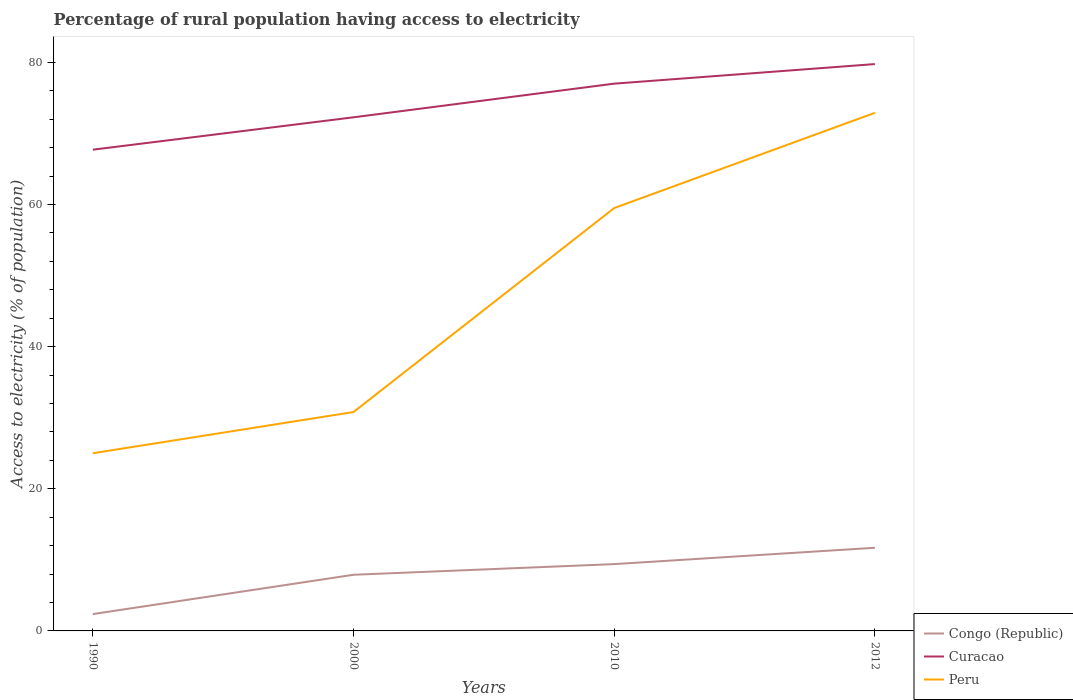How many different coloured lines are there?
Make the answer very short. 3. Across all years, what is the maximum percentage of rural population having access to electricity in Congo (Republic)?
Give a very brief answer. 2.37. In which year was the percentage of rural population having access to electricity in Congo (Republic) maximum?
Your response must be concise. 1990. What is the total percentage of rural population having access to electricity in Peru in the graph?
Provide a short and direct response. -28.7. What is the difference between the highest and the second highest percentage of rural population having access to electricity in Congo (Republic)?
Offer a terse response. 9.33. How many lines are there?
Keep it short and to the point. 3. How many years are there in the graph?
Ensure brevity in your answer.  4. Are the values on the major ticks of Y-axis written in scientific E-notation?
Your response must be concise. No. Does the graph contain any zero values?
Keep it short and to the point. No. Does the graph contain grids?
Offer a terse response. No. How are the legend labels stacked?
Your answer should be compact. Vertical. What is the title of the graph?
Keep it short and to the point. Percentage of rural population having access to electricity. Does "Eritrea" appear as one of the legend labels in the graph?
Your answer should be compact. No. What is the label or title of the Y-axis?
Provide a short and direct response. Access to electricity (% of population). What is the Access to electricity (% of population) of Congo (Republic) in 1990?
Make the answer very short. 2.37. What is the Access to electricity (% of population) of Curacao in 1990?
Provide a succinct answer. 67.71. What is the Access to electricity (% of population) in Peru in 1990?
Give a very brief answer. 25. What is the Access to electricity (% of population) of Curacao in 2000?
Your answer should be very brief. 72.27. What is the Access to electricity (% of population) in Peru in 2000?
Your answer should be very brief. 30.8. What is the Access to electricity (% of population) in Congo (Republic) in 2010?
Keep it short and to the point. 9.4. What is the Access to electricity (% of population) of Curacao in 2010?
Keep it short and to the point. 77. What is the Access to electricity (% of population) in Peru in 2010?
Make the answer very short. 59.5. What is the Access to electricity (% of population) of Curacao in 2012?
Keep it short and to the point. 79.75. What is the Access to electricity (% of population) of Peru in 2012?
Make the answer very short. 72.9. Across all years, what is the maximum Access to electricity (% of population) of Curacao?
Make the answer very short. 79.75. Across all years, what is the maximum Access to electricity (% of population) in Peru?
Make the answer very short. 72.9. Across all years, what is the minimum Access to electricity (% of population) of Congo (Republic)?
Make the answer very short. 2.37. Across all years, what is the minimum Access to electricity (% of population) in Curacao?
Your answer should be compact. 67.71. What is the total Access to electricity (% of population) of Congo (Republic) in the graph?
Offer a very short reply. 31.37. What is the total Access to electricity (% of population) in Curacao in the graph?
Ensure brevity in your answer.  296.73. What is the total Access to electricity (% of population) in Peru in the graph?
Ensure brevity in your answer.  188.2. What is the difference between the Access to electricity (% of population) in Congo (Republic) in 1990 and that in 2000?
Offer a terse response. -5.53. What is the difference between the Access to electricity (% of population) in Curacao in 1990 and that in 2000?
Your answer should be very brief. -4.55. What is the difference between the Access to electricity (% of population) in Congo (Republic) in 1990 and that in 2010?
Offer a very short reply. -7.03. What is the difference between the Access to electricity (% of population) in Curacao in 1990 and that in 2010?
Ensure brevity in your answer.  -9.29. What is the difference between the Access to electricity (% of population) in Peru in 1990 and that in 2010?
Keep it short and to the point. -34.5. What is the difference between the Access to electricity (% of population) in Congo (Republic) in 1990 and that in 2012?
Keep it short and to the point. -9.33. What is the difference between the Access to electricity (% of population) of Curacao in 1990 and that in 2012?
Offer a terse response. -12.04. What is the difference between the Access to electricity (% of population) of Peru in 1990 and that in 2012?
Keep it short and to the point. -47.9. What is the difference between the Access to electricity (% of population) of Curacao in 2000 and that in 2010?
Provide a succinct answer. -4.74. What is the difference between the Access to electricity (% of population) in Peru in 2000 and that in 2010?
Your response must be concise. -28.7. What is the difference between the Access to electricity (% of population) in Curacao in 2000 and that in 2012?
Make the answer very short. -7.49. What is the difference between the Access to electricity (% of population) of Peru in 2000 and that in 2012?
Your answer should be very brief. -42.1. What is the difference between the Access to electricity (% of population) in Curacao in 2010 and that in 2012?
Ensure brevity in your answer.  -2.75. What is the difference between the Access to electricity (% of population) of Peru in 2010 and that in 2012?
Keep it short and to the point. -13.4. What is the difference between the Access to electricity (% of population) of Congo (Republic) in 1990 and the Access to electricity (% of population) of Curacao in 2000?
Offer a terse response. -69.9. What is the difference between the Access to electricity (% of population) in Congo (Republic) in 1990 and the Access to electricity (% of population) in Peru in 2000?
Keep it short and to the point. -28.43. What is the difference between the Access to electricity (% of population) in Curacao in 1990 and the Access to electricity (% of population) in Peru in 2000?
Make the answer very short. 36.91. What is the difference between the Access to electricity (% of population) of Congo (Republic) in 1990 and the Access to electricity (% of population) of Curacao in 2010?
Ensure brevity in your answer.  -74.63. What is the difference between the Access to electricity (% of population) in Congo (Republic) in 1990 and the Access to electricity (% of population) in Peru in 2010?
Ensure brevity in your answer.  -57.13. What is the difference between the Access to electricity (% of population) in Curacao in 1990 and the Access to electricity (% of population) in Peru in 2010?
Your answer should be very brief. 8.21. What is the difference between the Access to electricity (% of population) in Congo (Republic) in 1990 and the Access to electricity (% of population) in Curacao in 2012?
Provide a short and direct response. -77.38. What is the difference between the Access to electricity (% of population) in Congo (Republic) in 1990 and the Access to electricity (% of population) in Peru in 2012?
Offer a very short reply. -70.53. What is the difference between the Access to electricity (% of population) in Curacao in 1990 and the Access to electricity (% of population) in Peru in 2012?
Keep it short and to the point. -5.19. What is the difference between the Access to electricity (% of population) of Congo (Republic) in 2000 and the Access to electricity (% of population) of Curacao in 2010?
Your response must be concise. -69.1. What is the difference between the Access to electricity (% of population) in Congo (Republic) in 2000 and the Access to electricity (% of population) in Peru in 2010?
Your answer should be very brief. -51.6. What is the difference between the Access to electricity (% of population) of Curacao in 2000 and the Access to electricity (% of population) of Peru in 2010?
Your response must be concise. 12.77. What is the difference between the Access to electricity (% of population) of Congo (Republic) in 2000 and the Access to electricity (% of population) of Curacao in 2012?
Ensure brevity in your answer.  -71.85. What is the difference between the Access to electricity (% of population) in Congo (Republic) in 2000 and the Access to electricity (% of population) in Peru in 2012?
Your answer should be compact. -65. What is the difference between the Access to electricity (% of population) of Curacao in 2000 and the Access to electricity (% of population) of Peru in 2012?
Offer a terse response. -0.64. What is the difference between the Access to electricity (% of population) in Congo (Republic) in 2010 and the Access to electricity (% of population) in Curacao in 2012?
Offer a terse response. -70.35. What is the difference between the Access to electricity (% of population) of Congo (Republic) in 2010 and the Access to electricity (% of population) of Peru in 2012?
Provide a succinct answer. -63.5. What is the average Access to electricity (% of population) of Congo (Republic) per year?
Make the answer very short. 7.84. What is the average Access to electricity (% of population) in Curacao per year?
Keep it short and to the point. 74.18. What is the average Access to electricity (% of population) of Peru per year?
Your answer should be very brief. 47.05. In the year 1990, what is the difference between the Access to electricity (% of population) in Congo (Republic) and Access to electricity (% of population) in Curacao?
Your answer should be compact. -65.34. In the year 1990, what is the difference between the Access to electricity (% of population) of Congo (Republic) and Access to electricity (% of population) of Peru?
Make the answer very short. -22.63. In the year 1990, what is the difference between the Access to electricity (% of population) in Curacao and Access to electricity (% of population) in Peru?
Your response must be concise. 42.71. In the year 2000, what is the difference between the Access to electricity (% of population) in Congo (Republic) and Access to electricity (% of population) in Curacao?
Your answer should be compact. -64.36. In the year 2000, what is the difference between the Access to electricity (% of population) in Congo (Republic) and Access to electricity (% of population) in Peru?
Your answer should be compact. -22.9. In the year 2000, what is the difference between the Access to electricity (% of population) in Curacao and Access to electricity (% of population) in Peru?
Give a very brief answer. 41.47. In the year 2010, what is the difference between the Access to electricity (% of population) in Congo (Republic) and Access to electricity (% of population) in Curacao?
Offer a terse response. -67.6. In the year 2010, what is the difference between the Access to electricity (% of population) in Congo (Republic) and Access to electricity (% of population) in Peru?
Give a very brief answer. -50.1. In the year 2012, what is the difference between the Access to electricity (% of population) in Congo (Republic) and Access to electricity (% of population) in Curacao?
Ensure brevity in your answer.  -68.05. In the year 2012, what is the difference between the Access to electricity (% of population) in Congo (Republic) and Access to electricity (% of population) in Peru?
Keep it short and to the point. -61.2. In the year 2012, what is the difference between the Access to electricity (% of population) in Curacao and Access to electricity (% of population) in Peru?
Offer a terse response. 6.85. What is the ratio of the Access to electricity (% of population) of Curacao in 1990 to that in 2000?
Ensure brevity in your answer.  0.94. What is the ratio of the Access to electricity (% of population) of Peru in 1990 to that in 2000?
Your answer should be very brief. 0.81. What is the ratio of the Access to electricity (% of population) in Congo (Republic) in 1990 to that in 2010?
Give a very brief answer. 0.25. What is the ratio of the Access to electricity (% of population) of Curacao in 1990 to that in 2010?
Your answer should be compact. 0.88. What is the ratio of the Access to electricity (% of population) in Peru in 1990 to that in 2010?
Offer a terse response. 0.42. What is the ratio of the Access to electricity (% of population) in Congo (Republic) in 1990 to that in 2012?
Offer a terse response. 0.2. What is the ratio of the Access to electricity (% of population) in Curacao in 1990 to that in 2012?
Offer a terse response. 0.85. What is the ratio of the Access to electricity (% of population) of Peru in 1990 to that in 2012?
Your response must be concise. 0.34. What is the ratio of the Access to electricity (% of population) in Congo (Republic) in 2000 to that in 2010?
Your response must be concise. 0.84. What is the ratio of the Access to electricity (% of population) in Curacao in 2000 to that in 2010?
Offer a very short reply. 0.94. What is the ratio of the Access to electricity (% of population) in Peru in 2000 to that in 2010?
Ensure brevity in your answer.  0.52. What is the ratio of the Access to electricity (% of population) in Congo (Republic) in 2000 to that in 2012?
Offer a very short reply. 0.68. What is the ratio of the Access to electricity (% of population) of Curacao in 2000 to that in 2012?
Offer a very short reply. 0.91. What is the ratio of the Access to electricity (% of population) in Peru in 2000 to that in 2012?
Offer a terse response. 0.42. What is the ratio of the Access to electricity (% of population) in Congo (Republic) in 2010 to that in 2012?
Your response must be concise. 0.8. What is the ratio of the Access to electricity (% of population) of Curacao in 2010 to that in 2012?
Your answer should be very brief. 0.97. What is the ratio of the Access to electricity (% of population) of Peru in 2010 to that in 2012?
Your response must be concise. 0.82. What is the difference between the highest and the second highest Access to electricity (% of population) of Congo (Republic)?
Ensure brevity in your answer.  2.3. What is the difference between the highest and the second highest Access to electricity (% of population) in Curacao?
Keep it short and to the point. 2.75. What is the difference between the highest and the second highest Access to electricity (% of population) in Peru?
Give a very brief answer. 13.4. What is the difference between the highest and the lowest Access to electricity (% of population) in Congo (Republic)?
Your response must be concise. 9.33. What is the difference between the highest and the lowest Access to electricity (% of population) of Curacao?
Keep it short and to the point. 12.04. What is the difference between the highest and the lowest Access to electricity (% of population) of Peru?
Offer a terse response. 47.9. 